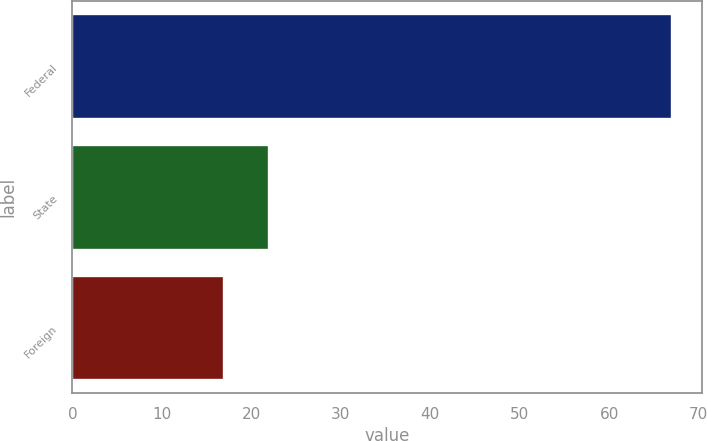Convert chart to OTSL. <chart><loc_0><loc_0><loc_500><loc_500><bar_chart><fcel>Federal<fcel>State<fcel>Foreign<nl><fcel>67<fcel>22<fcel>17<nl></chart> 